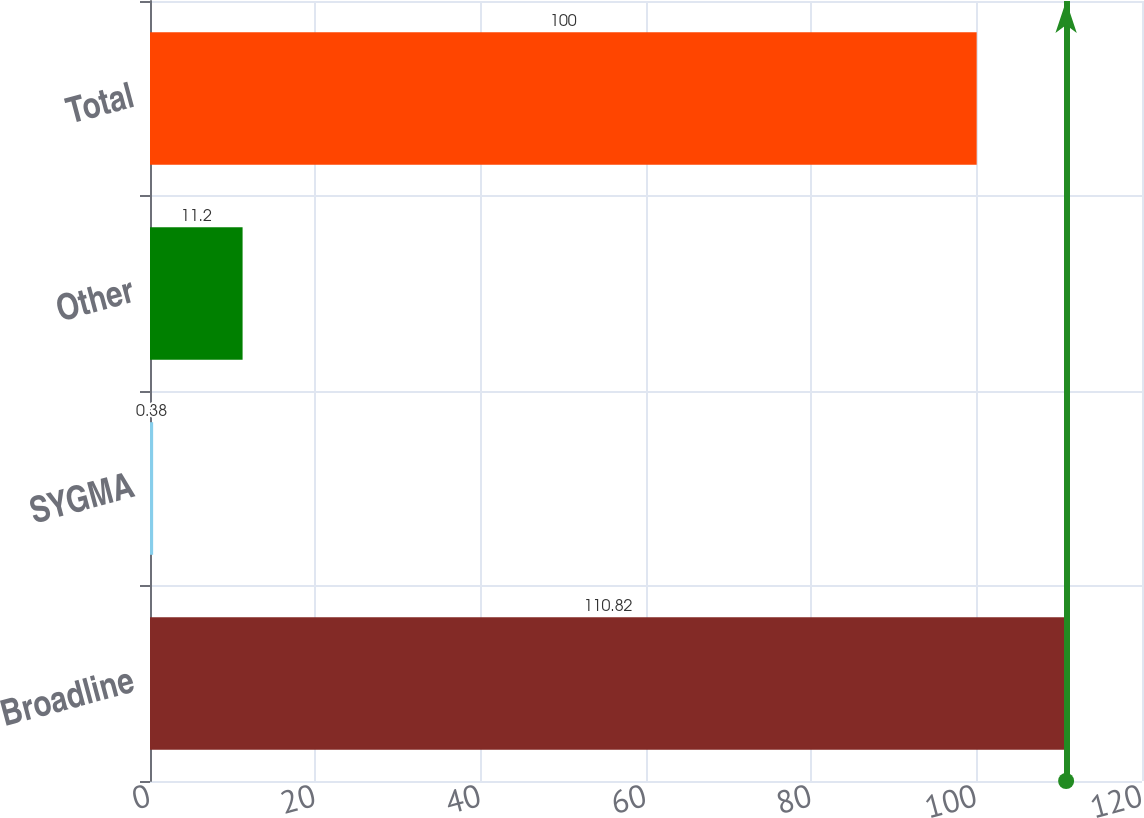Convert chart. <chart><loc_0><loc_0><loc_500><loc_500><bar_chart><fcel>Broadline<fcel>SYGMA<fcel>Other<fcel>Total<nl><fcel>110.82<fcel>0.38<fcel>11.2<fcel>100<nl></chart> 